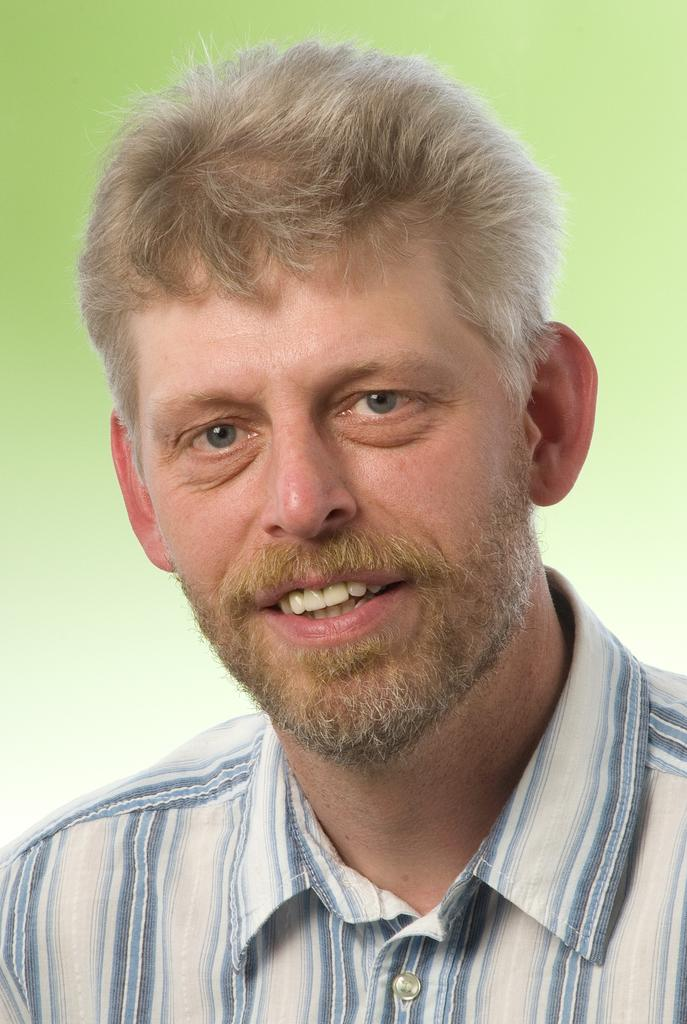What is the main subject of the image? There is a man in the image. What is the man's facial expression? The man is smiling. What color is the background of the image? The background of the image is light green. Can you see a rifle in the man's hand in the image? There is no rifle present in the image. What type of prison can be seen in the background of the image? There is no prison present in the image; the background is light green. 